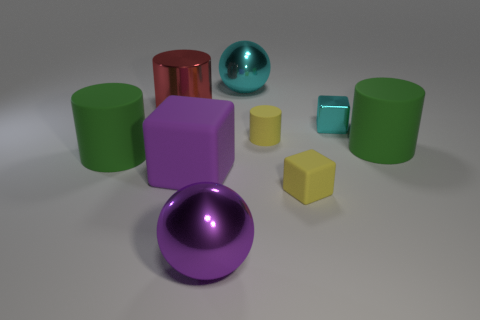Are there more purple rubber cubes that are to the left of the shiny cylinder than tiny green matte spheres?
Offer a terse response. No. Do the purple metal thing and the cyan object that is in front of the metal cylinder have the same shape?
Keep it short and to the point. No. Are there any other things that have the same size as the purple block?
Give a very brief answer. Yes. What size is the yellow thing that is the same shape as the red object?
Provide a succinct answer. Small. Are there more green cylinders than small brown matte balls?
Give a very brief answer. Yes. Does the small cyan metallic thing have the same shape as the purple shiny thing?
Your answer should be compact. No. What material is the ball that is in front of the large green cylinder that is to the left of the red object?
Provide a short and direct response. Metal. There is a cylinder that is the same color as the small rubber block; what material is it?
Make the answer very short. Rubber. Is the purple ball the same size as the red metal cylinder?
Make the answer very short. Yes. Are there any large green cylinders that are behind the yellow thing that is to the right of the tiny cylinder?
Offer a very short reply. Yes. 